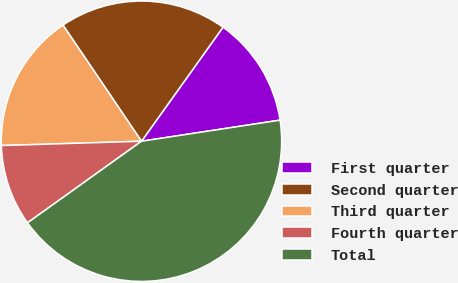<chart> <loc_0><loc_0><loc_500><loc_500><pie_chart><fcel>First quarter<fcel>Second quarter<fcel>Third quarter<fcel>Fourth quarter<fcel>Total<nl><fcel>12.72%<fcel>19.34%<fcel>16.03%<fcel>9.4%<fcel>42.52%<nl></chart> 